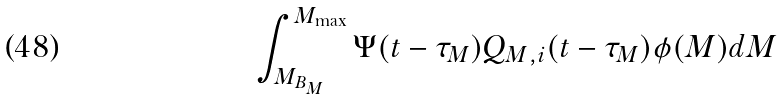Convert formula to latex. <formula><loc_0><loc_0><loc_500><loc_500>\int _ { M _ { B _ { M } } } ^ { M _ { \max } } \Psi ( t - \tau _ { M } ) Q _ { M , i } ( t - \tau _ { M } ) \phi ( M ) d M</formula> 